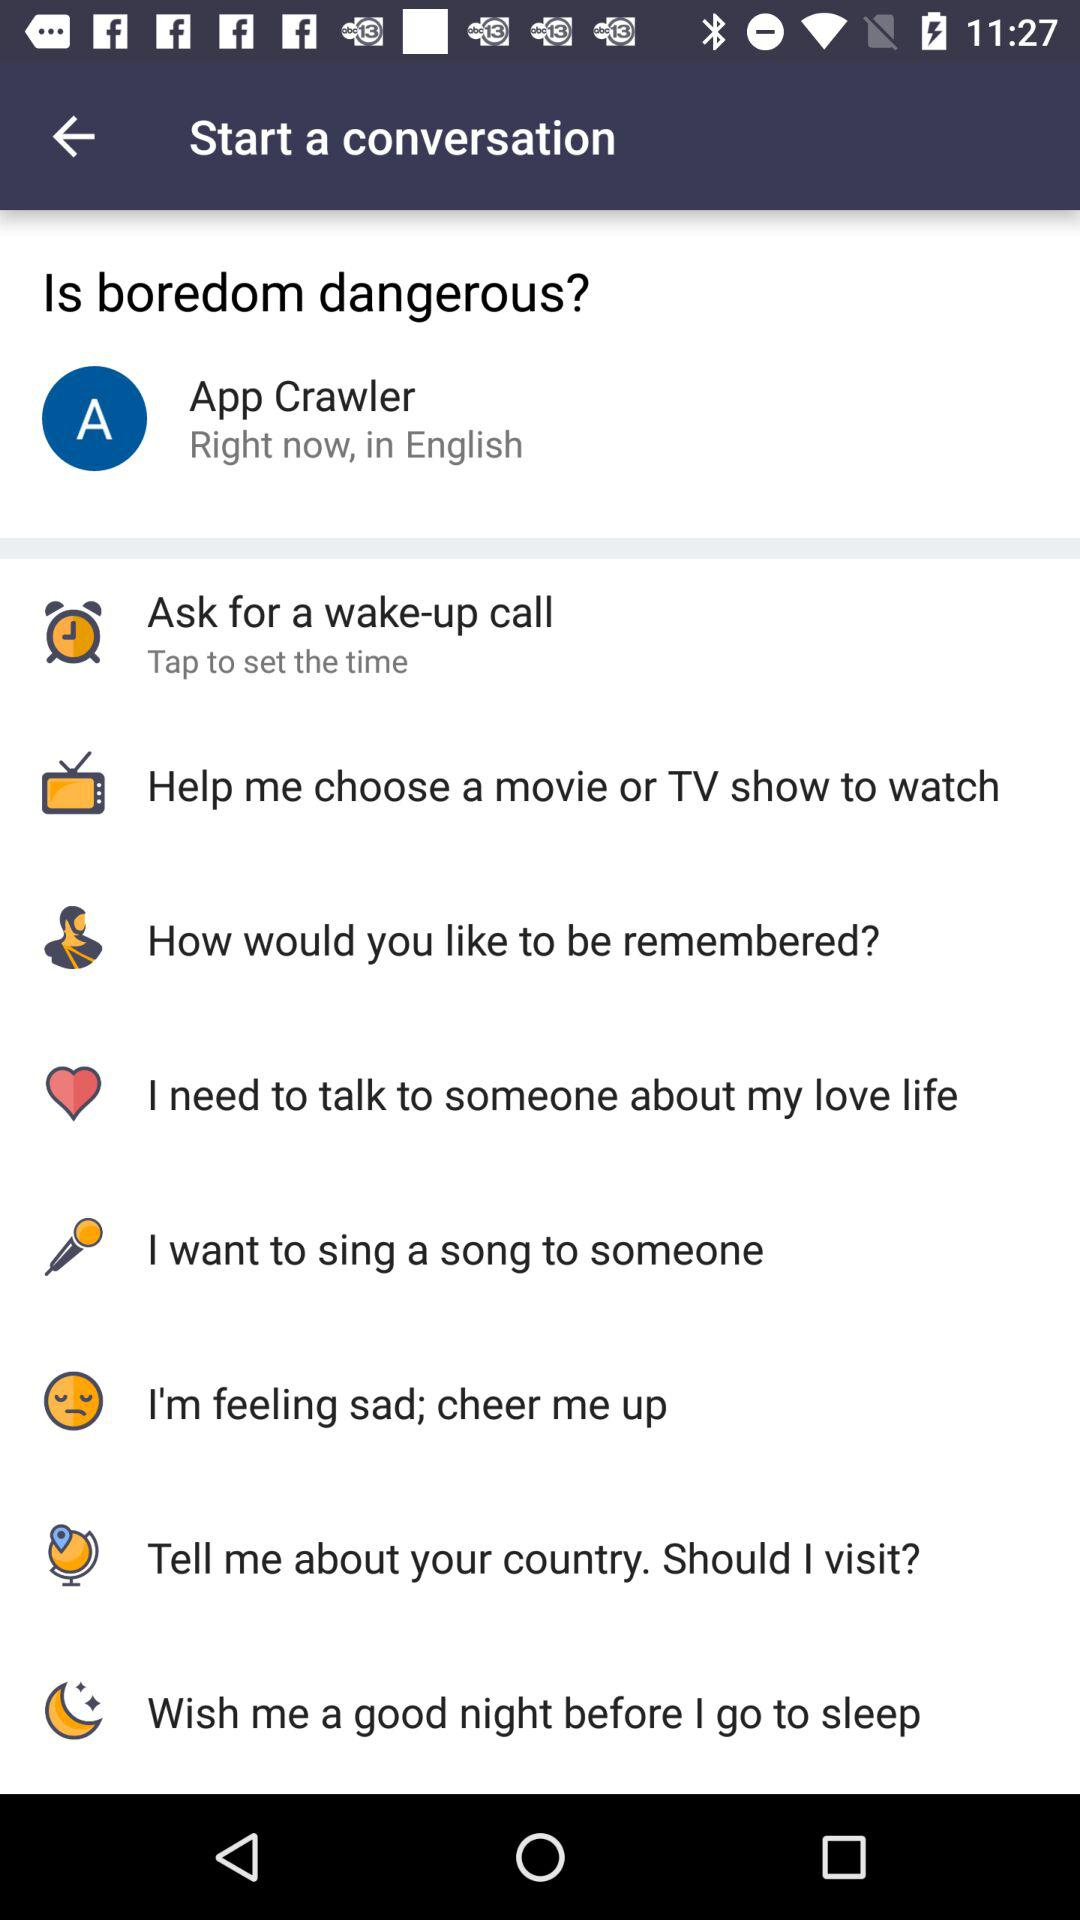What is the user name? The user name is App Crawler. 